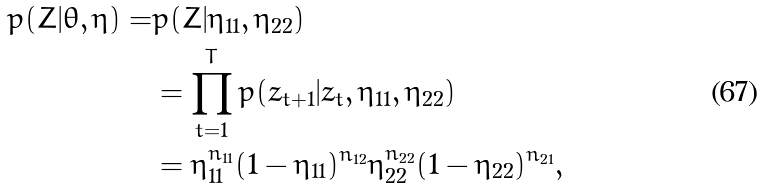<formula> <loc_0><loc_0><loc_500><loc_500>p ( Z | \theta , \eta ) = & p ( Z | \eta _ { 1 1 } , \eta _ { 2 2 } ) \\ & = \prod _ { t = 1 } ^ { T } { p ( z _ { t + 1 } | z _ { t } , \eta _ { 1 1 } , \eta _ { 2 2 } ) } \\ & = \eta _ { 1 1 } ^ { n _ { 1 1 } } ( 1 - \eta _ { 1 1 } ) ^ { n _ { 1 2 } } \eta _ { 2 2 } ^ { n _ { 2 2 } } ( 1 - \eta _ { 2 2 } ) ^ { n _ { 2 1 } } ,</formula> 